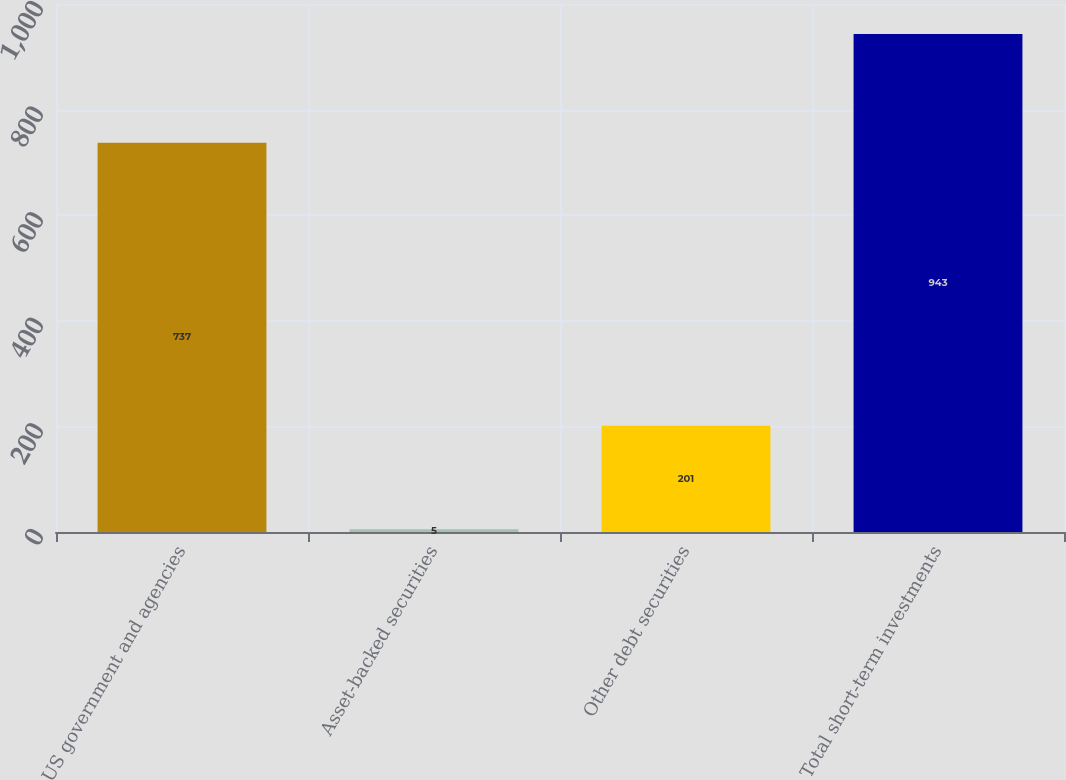Convert chart. <chart><loc_0><loc_0><loc_500><loc_500><bar_chart><fcel>US government and agencies<fcel>Asset-backed securities<fcel>Other debt securities<fcel>Total short-term investments<nl><fcel>737<fcel>5<fcel>201<fcel>943<nl></chart> 